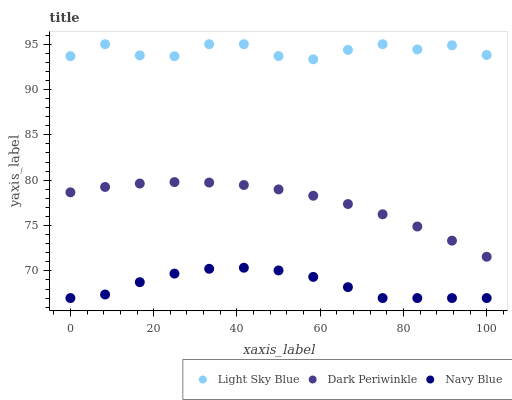Does Navy Blue have the minimum area under the curve?
Answer yes or no. Yes. Does Light Sky Blue have the maximum area under the curve?
Answer yes or no. Yes. Does Dark Periwinkle have the minimum area under the curve?
Answer yes or no. No. Does Dark Periwinkle have the maximum area under the curve?
Answer yes or no. No. Is Dark Periwinkle the smoothest?
Answer yes or no. Yes. Is Light Sky Blue the roughest?
Answer yes or no. Yes. Is Light Sky Blue the smoothest?
Answer yes or no. No. Is Dark Periwinkle the roughest?
Answer yes or no. No. Does Navy Blue have the lowest value?
Answer yes or no. Yes. Does Dark Periwinkle have the lowest value?
Answer yes or no. No. Does Light Sky Blue have the highest value?
Answer yes or no. Yes. Does Dark Periwinkle have the highest value?
Answer yes or no. No. Is Navy Blue less than Light Sky Blue?
Answer yes or no. Yes. Is Light Sky Blue greater than Navy Blue?
Answer yes or no. Yes. Does Navy Blue intersect Light Sky Blue?
Answer yes or no. No. 